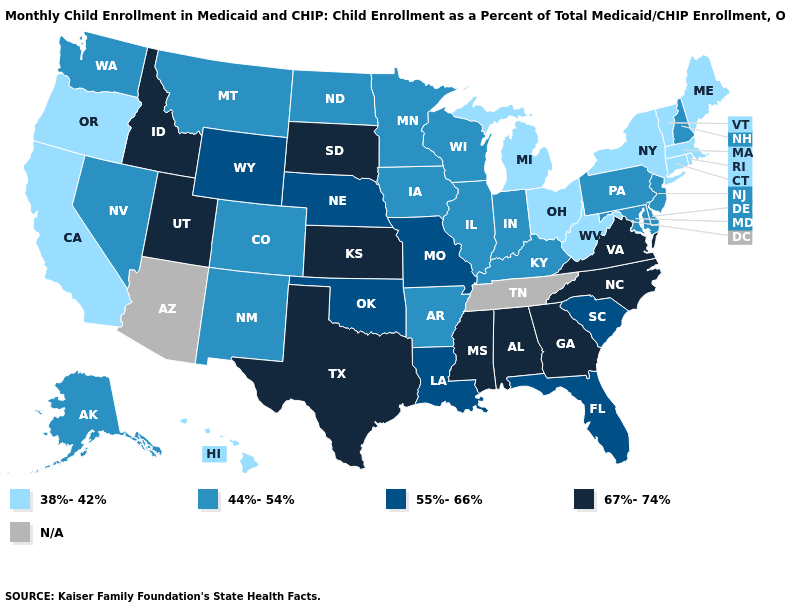Name the states that have a value in the range 67%-74%?
Give a very brief answer. Alabama, Georgia, Idaho, Kansas, Mississippi, North Carolina, South Dakota, Texas, Utah, Virginia. What is the lowest value in states that border Georgia?
Write a very short answer. 55%-66%. What is the lowest value in states that border North Dakota?
Keep it brief. 44%-54%. What is the lowest value in the USA?
Keep it brief. 38%-42%. What is the highest value in the Northeast ?
Concise answer only. 44%-54%. What is the highest value in the Northeast ?
Write a very short answer. 44%-54%. Name the states that have a value in the range 55%-66%?
Concise answer only. Florida, Louisiana, Missouri, Nebraska, Oklahoma, South Carolina, Wyoming. Does Kansas have the highest value in the USA?
Quick response, please. Yes. Name the states that have a value in the range 44%-54%?
Be succinct. Alaska, Arkansas, Colorado, Delaware, Illinois, Indiana, Iowa, Kentucky, Maryland, Minnesota, Montana, Nevada, New Hampshire, New Jersey, New Mexico, North Dakota, Pennsylvania, Washington, Wisconsin. What is the value of Iowa?
Concise answer only. 44%-54%. Name the states that have a value in the range N/A?
Be succinct. Arizona, Tennessee. Is the legend a continuous bar?
Be succinct. No. Name the states that have a value in the range 44%-54%?
Write a very short answer. Alaska, Arkansas, Colorado, Delaware, Illinois, Indiana, Iowa, Kentucky, Maryland, Minnesota, Montana, Nevada, New Hampshire, New Jersey, New Mexico, North Dakota, Pennsylvania, Washington, Wisconsin. 